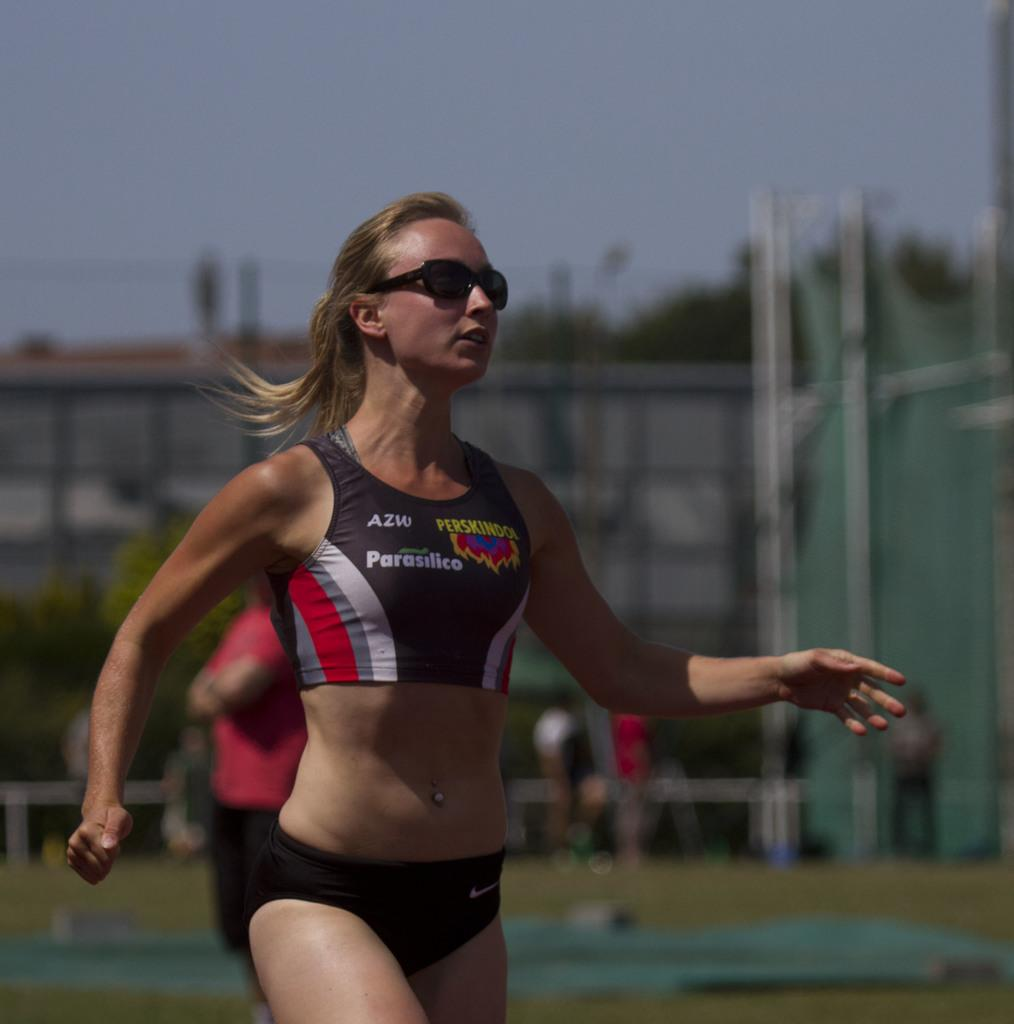<image>
Give a short and clear explanation of the subsequent image. female runner with sponsor ads on her top for azw, parasilico, and perskindol 